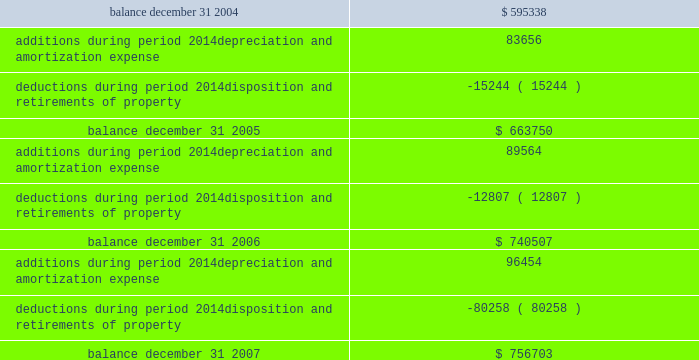Federal realty investment trust schedule iii summary of real estate and accumulated depreciation 2014continued three years ended december 31 , 2007 reconciliation of accumulated depreciation and amortization ( in thousands ) .

What is the increase in the deductions during 2006 and 2007 , in thousands of dollars? 
Rationale: it is the difference between those deduction values .
Computations: (80258 - 12807)
Answer: 67451.0. 